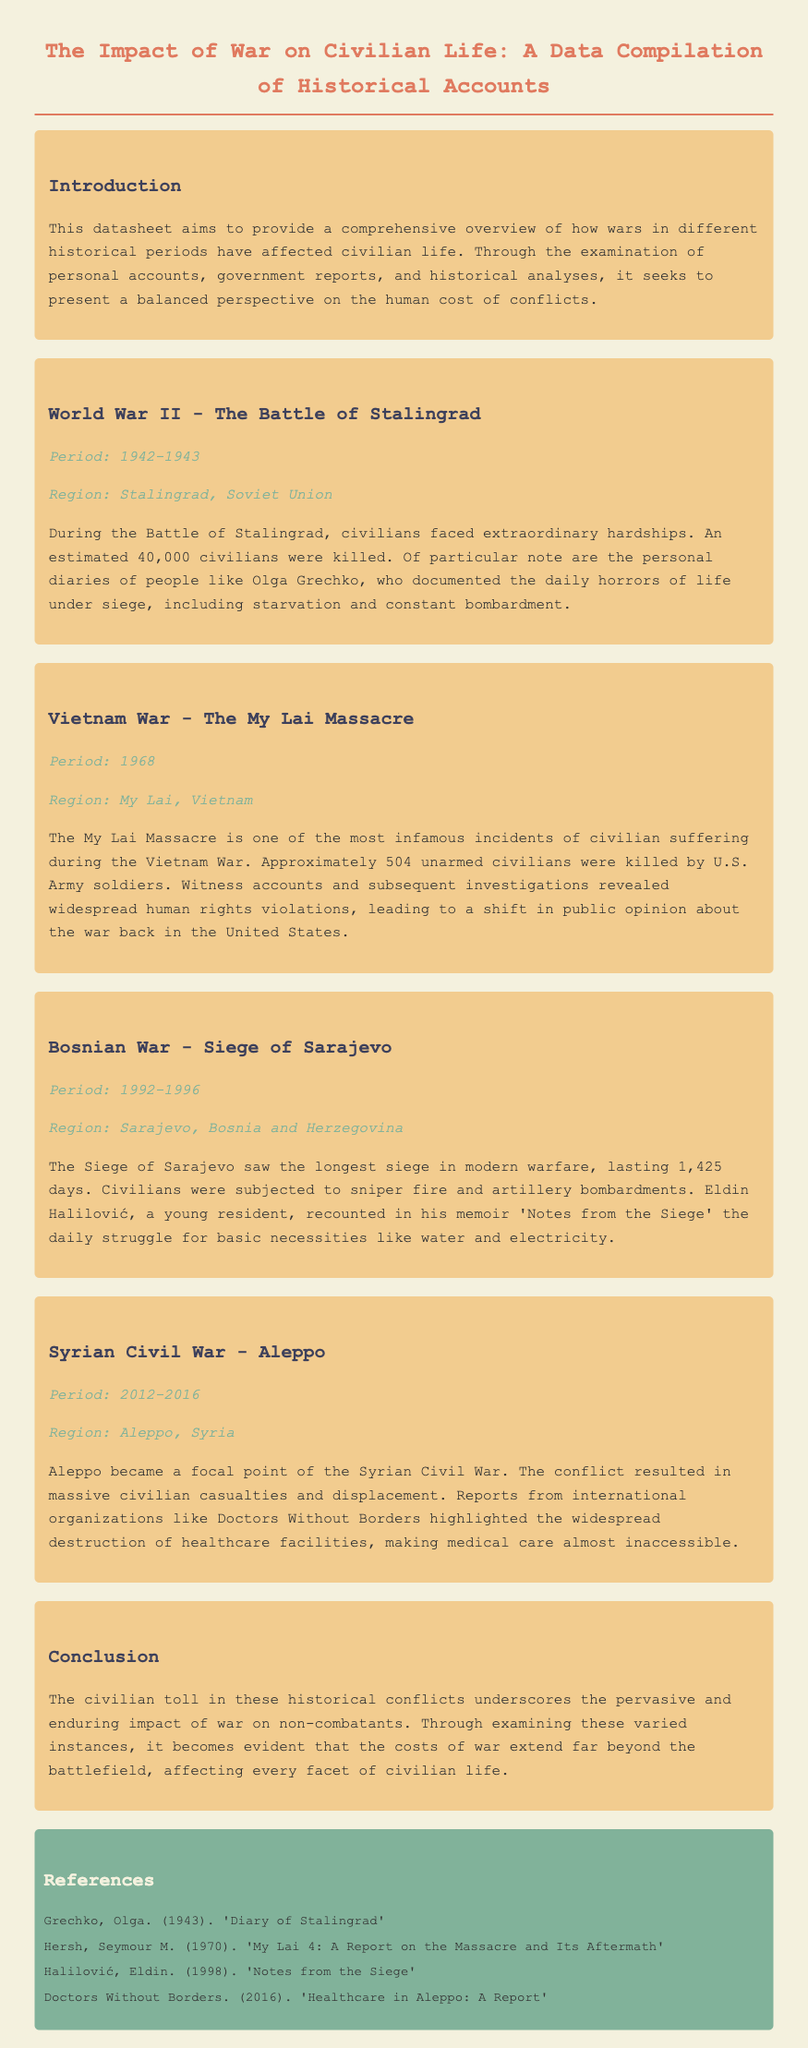What was the estimated number of civilian deaths in Stalingrad? The document states that approximately 40,000 civilians were killed during the Battle of Stalingrad.
Answer: 40,000 When did the My Lai Massacre occur? The My Lai Massacre is noted to have happened in 1968 according to the document.
Answer: 1968 Who documented the events during the Siege of Stalingrad? Olga Grechko is mentioned as a person who documented the daily horrors of life under siege in her diaries.
Answer: Olga Grechko What was the duration of the Siege of Sarajevo? The document mentions that the Siege of Sarajevo lasted 1,425 days.
Answer: 1,425 days Which region experienced massive civilian casualties and displacement in the documented Syrian conflict? The document specifies Aleppo as the region that experienced massive civilian casualties and displacement during the Syrian Civil War.
Answer: Aleppo What aspect of civilian life was severely impacted in Aleppo? The reports highlighted the widespread destruction of healthcare facilities, impacting medical care access for civilians.
Answer: Healthcare facilities What type of document is this compilation classified as? This compilation is classified as a datasheet that provides a comprehensive overview of historical accounts relating to civilian life during wars.
Answer: Datasheet What does the introduction emphasize about the documentation? The introduction emphasizes the aim to present a balanced perspective on the human cost of conflicts through various forms of accounts.
Answer: Balanced perspective Which war was the Siege of Sarajevo associated with? The document clearly associates the Siege of Sarajevo with the Bosnian War.
Answer: Bosnian War 